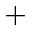Convert formula to latex. <formula><loc_0><loc_0><loc_500><loc_500>^ { + }</formula> 